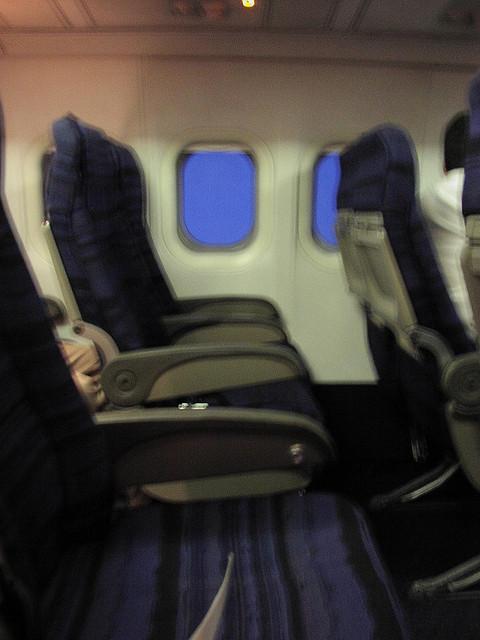How many chairs are there?
Give a very brief answer. 3. 